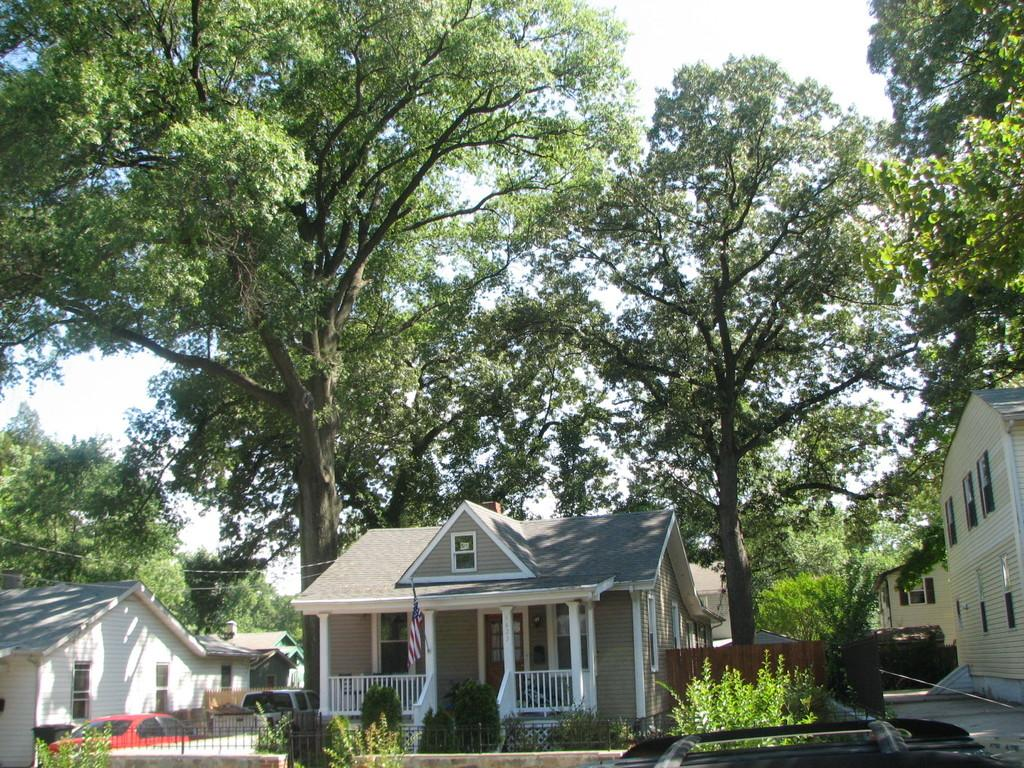What type of vegetation is located in the middle of the image? There are trees in the middle of the image. What structures are present at the bottom of the image? There are houses and plants at the bottom of the image. What type of vehicles can be seen on the left side of the image? There are cars on the left side of the image. Where is the toothbrush located in the image? There is no toothbrush present in the image. What type of food is being served in the lunchroom in the image? There is no lunchroom present in the image. 